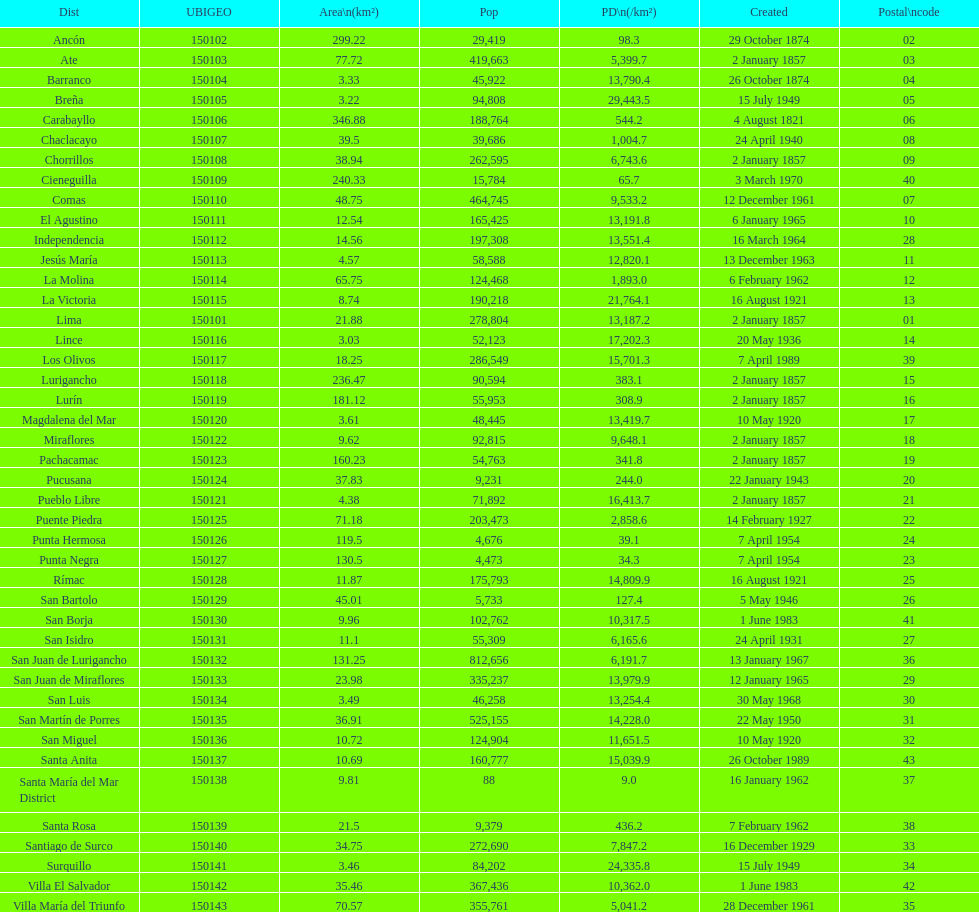What was the most recent district established? Santa Anita. 